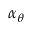<formula> <loc_0><loc_0><loc_500><loc_500>\alpha _ { \theta }</formula> 